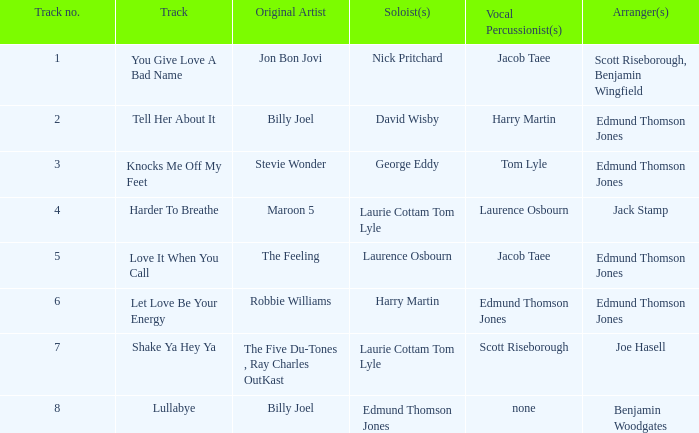How many tracks have the title let love be your energy? 1.0. 